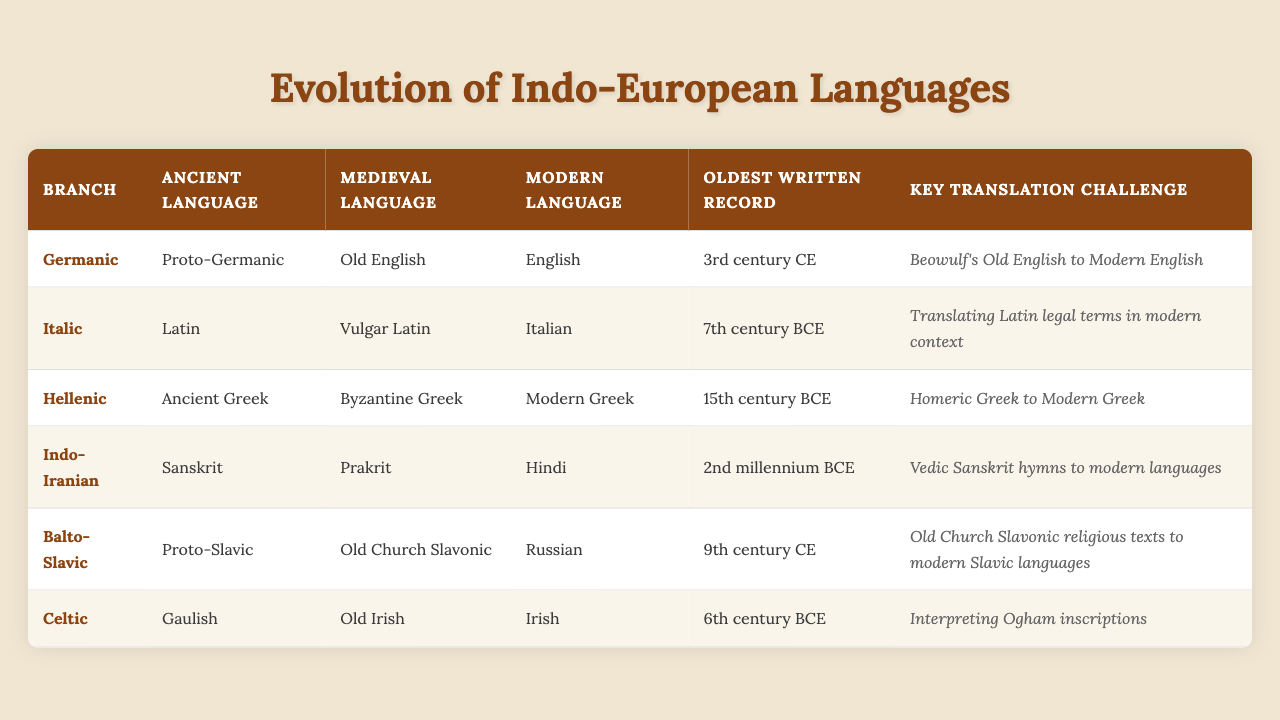What is the modern language derived from the Hellenic branch? The Hellenic branch lists "Modern Greek" as its modern language. This information can be directly found in the corresponding row for the Hellenic branch.
Answer: Modern Greek Which ancient language has the oldest written record? By scanning through the table, we find that "Ancient Greek" under the Hellenic branch has the oldest written record dating back to the 15th century BCE, which is earlier than other records listed.
Answer: Ancient Greek How many language branches have a medieval language that is Old English? The table only has the Germanic branch listed with "Old English" as its medieval language. Therefore, there’s only one such branch.
Answer: 1 Is the oldest written record for the Balto-Slavic branch earlier than that for the Celtic branch? The Balto-Slavic branch's oldest written record is from the 9th century CE, while the Celtic branch’s oldest record is from the 6th century BCE. Since BCE dates are older than CE dates, the statement is true.
Answer: Yes What is the key translation challenge for the Italic branch? The Italic branch specifies the key translation challenge as "Translating Latin legal terms in modern context", which can be found in the respective row under the Key Translation Challenge column.
Answer: Translating Latin legal terms in modern context Which language branch has the most recent oldest written record? Looking through the table, the Germanic branch has its oldest written record as from the 3rd century CE, which is the most recent compared to others that are either BCE or earlier CE dates.
Answer: Germanic Count the number of language branches that have their oldest written records from the BCE period. The table shows that the Italic, Hellenic, Indo-Iranian, and Celtic branches have their oldest written records in the BCE period, which gives a total of four.
Answer: 4 What is the relationship between the medieval language "Old Irish" and the modern language "Irish"? The table indicates that "Old Irish" is the medieval language that evolved into the modern language "Irish" in the Celtic branch, demonstrating a direct lineage.
Answer: Old Irish evolved into Irish Which ancient language corresponds to the key translation challenge of interpreting Ogham inscriptions? The question corresponds to the Celtic branch, where "Gaulish" is identified as the ancient language and relates to the challenge of interpreting Ogham inscriptions.
Answer: Gaulish If you were to summarize the translation challenges across all branches, what is the only language that poses a challenge related to religious texts? The Balto-Slavic branch presents "Old Church Slavonic religious texts to modern Slavic languages" as its key translation challenge, making it the singular case among all branches concerning religious texts.
Answer: Old Church Slavonic 